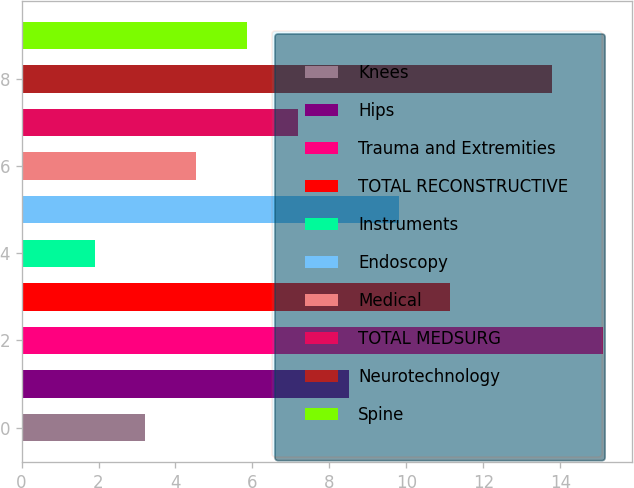<chart> <loc_0><loc_0><loc_500><loc_500><bar_chart><fcel>Knees<fcel>Hips<fcel>Trauma and Extremities<fcel>TOTAL RECONSTRUCTIVE<fcel>Instruments<fcel>Endoscopy<fcel>Medical<fcel>TOTAL MEDSURG<fcel>Neurotechnology<fcel>Spine<nl><fcel>3.22<fcel>8.5<fcel>15.1<fcel>11.14<fcel>1.9<fcel>9.82<fcel>4.54<fcel>7.18<fcel>13.78<fcel>5.86<nl></chart> 